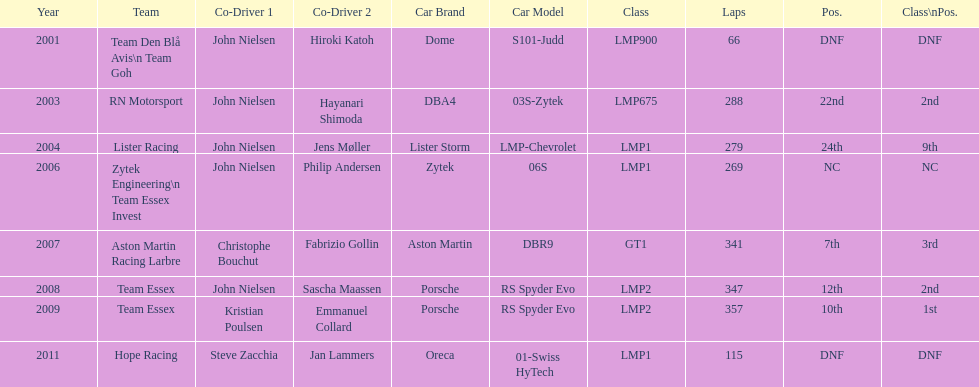Could you parse the entire table as a dict? {'header': ['Year', 'Team', 'Co-Driver 1', 'Co-Driver 2', 'Car Brand', 'Car Model', 'Class', 'Laps', 'Pos.', 'Class\\nPos.'], 'rows': [['2001', 'Team Den Blå Avis\\n Team Goh', 'John Nielsen', 'Hiroki Katoh', 'Dome', 'S101-Judd', 'LMP900', '66', 'DNF', 'DNF'], ['2003', 'RN Motorsport', 'John Nielsen', 'Hayanari Shimoda', 'DBA4', '03S-Zytek', 'LMP675', '288', '22nd', '2nd'], ['2004', 'Lister Racing', 'John Nielsen', 'Jens Møller', 'Lister Storm', 'LMP-Chevrolet', 'LMP1', '279', '24th', '9th'], ['2006', 'Zytek Engineering\\n Team Essex Invest', 'John Nielsen', 'Philip Andersen', 'Zytek', '06S', 'LMP1', '269', 'NC', 'NC'], ['2007', 'Aston Martin Racing Larbre', 'Christophe Bouchut', 'Fabrizio Gollin', 'Aston Martin', 'DBR9', 'GT1', '341', '7th', '3rd'], ['2008', 'Team Essex', 'John Nielsen', 'Sascha Maassen', 'Porsche', 'RS Spyder Evo', 'LMP2', '347', '12th', '2nd'], ['2009', 'Team Essex', 'Kristian Poulsen', 'Emmanuel Collard', 'Porsche', 'RS Spyder Evo', 'LMP2', '357', '10th', '1st'], ['2011', 'Hope Racing', 'Steve Zacchia', 'Jan Lammers', 'Oreca', '01-Swiss HyTech', 'LMP1', '115', 'DNF', 'DNF']]} What is the amount races that were competed in? 8. 